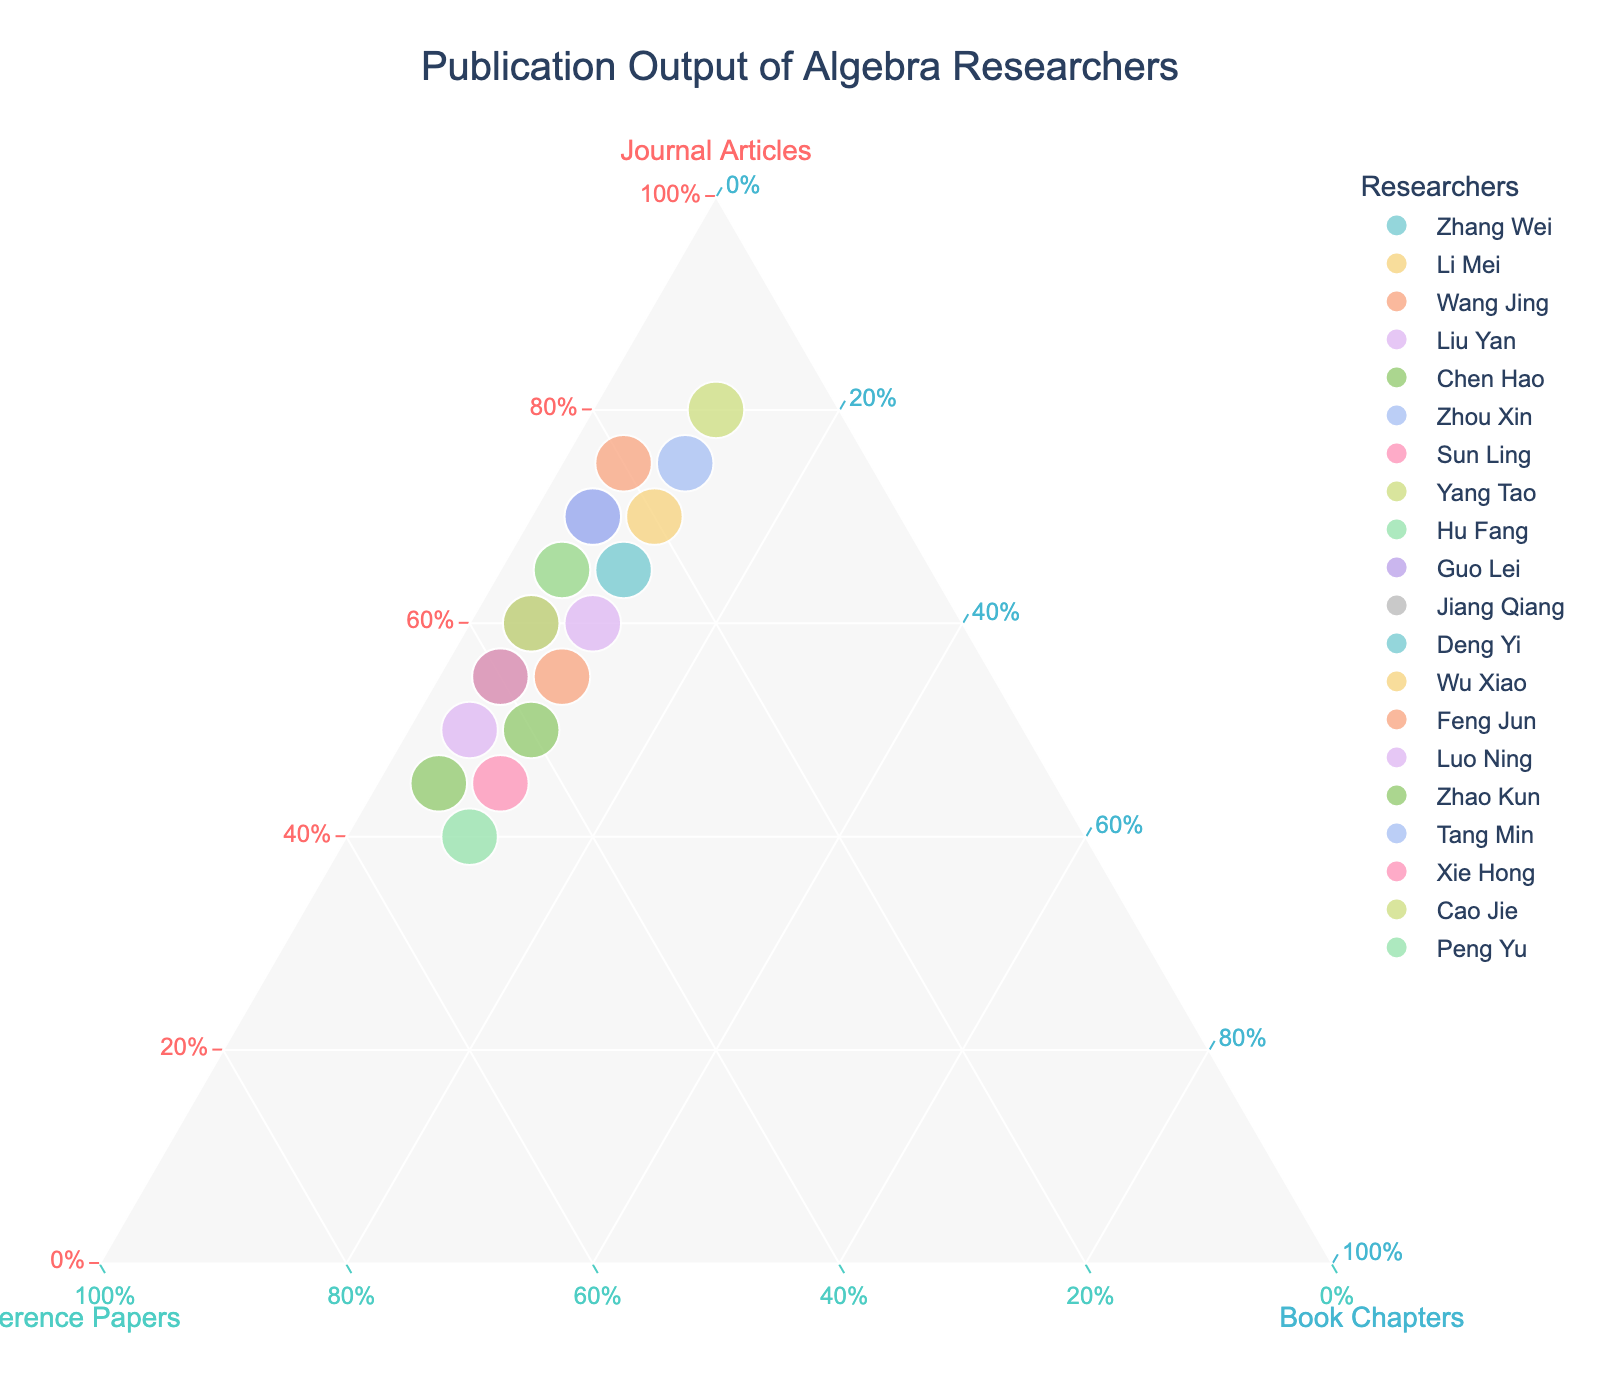What is the title of the figure? The title is usually located at the top of the figure and is aimed to give a clear idea about what the plot represents. In this case, it is mentioned in the code used for generating the figure.
Answer: Publication Output of Algebra Researchers Which researcher has the highest proportion of journal articles in their publication output? To determine this, locate the data point that is nearest to the vertex labeled 'Journal Articles'. This point represents the highest proportion of journal articles.
Answer: Yang Tao What are the proportions of journal articles, conference papers, and book chapters for Zhang Wei? Each point on the ternary plot represents a researcher's proportions of the three categories. By examining Zhang Wei's position, the proportions can be read directly.
Answer: 65% Journal Articles, 25% Conference Papers, 10% Book Chapters Compare the publication outputs of Zhou Xin and Hu Fang in terms of the proportions of journal articles. Who has a higher proportion? To compare these two researchers, find their respective points on the ternary plot and see which one is closer to the vertex labeled 'Journal Articles'.
Answer: Zhou Xin How many researchers have a higher proportion of conference papers compared to journal articles? To identify this, locate the points that are situated closer to the vertex labeled 'Conference Papers' than to the vertex labeled 'Journal Articles'. Count these points to find the answer.
Answer: 5 researchers Which researcher has the closest proportional distribution between journal articles and book chapters? Look for the data point that lies nearest to the line that equally divides the triangle between 'Journal Articles' and 'Book Chapters'. This point represents the closest proportional distribution between these two categories.
Answer: Tang Min What are the common features among researchers with exactly 10% book chapters in their publication output? Identify the researchers with 10% book chapters by locating the points along the line dividing 'Book Chapters' at 10%. Observe their positions relative to the other two axes for any common features.
Answer: Nearly all have a strong emphasis on either journal articles or conference papers Whose publication output is balanced among the three categories? In a ternary plot, balanced outputs are represented by points centrally located within the triangle. Find the point that appears most centrally located.
Answer: Liu Yan Which researcher has the most diversified publication output, considering all three categories? The most diversified publication output means nearly equal proportions in all three categories, represented by a point near the center of the ternary plot.
Answer: Sun Ling How does Feng Jun's publication output compare to Guo Lei in terms of book chapters? To compare, locate both researchers' points and see their positions relative to the vertex labeled 'Book Chapters'. Checking the values confirms whether one has a higher proportion than the other.
Answer: Guo Lei has more (5%) compared to Feng Jun (5%) 